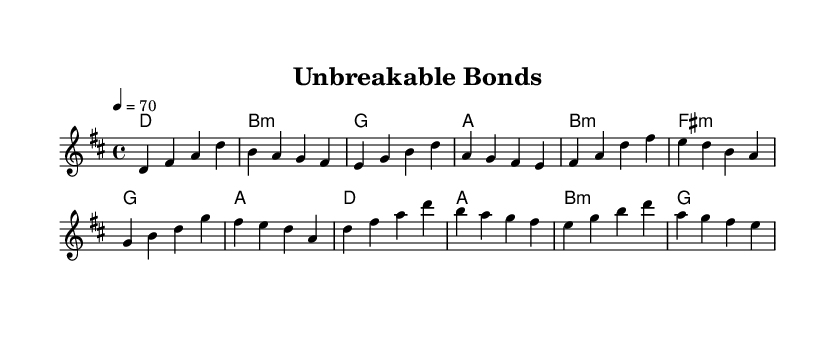What is the key signature of this music? The key signature is D major, which has two sharps (F# and C#). This can be identified from the key signature indicated at the beginning of the score.
Answer: D major What is the time signature of this music? The time signature is 4/4, which is indicated at the beginning of the score. It signifies that there are four beats in each measure and a quarter note receives one beat.
Answer: 4/4 What is the tempo marking of this piece? The tempo marking indicates a speed of 70 beats per minute, expressed in the score as "4 = 70." This shows that the quarter note is to be played at this speed.
Answer: 70 How many measures are in the verse section? The verse section consists of four measures, as can be counted within the melody part, which is marked by the lyrics or thematic material in the score.
Answer: 4 What are the harmonies used in the chorus? The harmonies in the chorus are D, A, B minor, and G, as can be seen in the chord changes aligned with the melody during the chorus section.
Answer: D, A, B minor, G What is the relationship between the key and the chords used? The chords used, particularly D, B minor, G, and A, are all diatonic to the key of D major, meaning they are derived from the notes of the D major scale. This establishes a cohesive harmonic structure throughout the piece.
Answer: Diatonic Which section of the music features a modulation? There is no modulation present in this score; all sections remain in the key of D major throughout the song, utilizing only the diatonic chords of that key.
Answer: None 